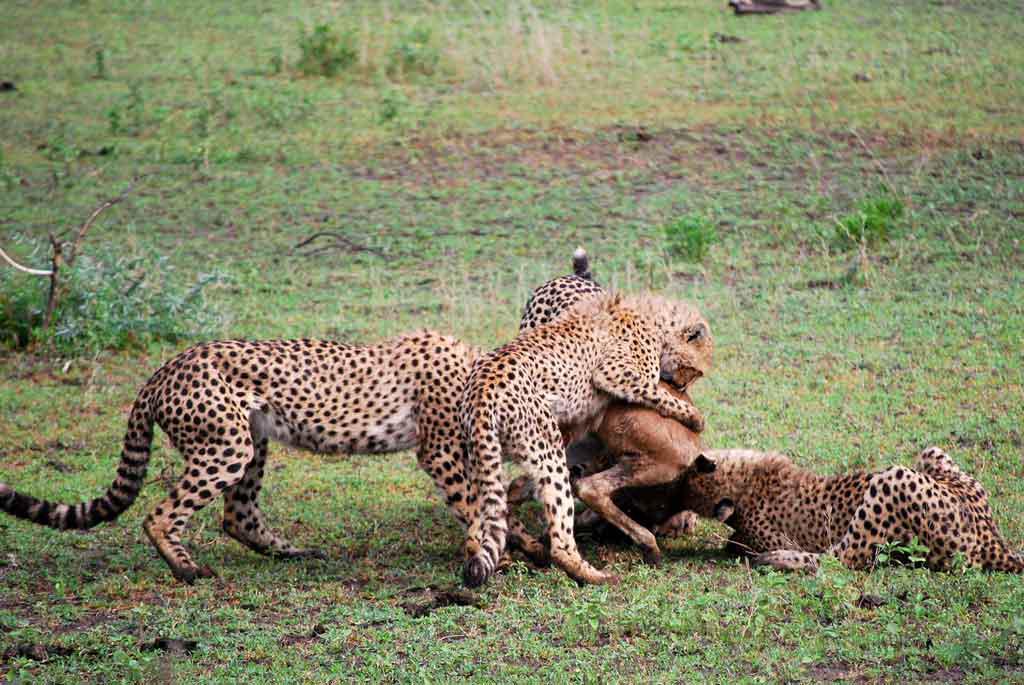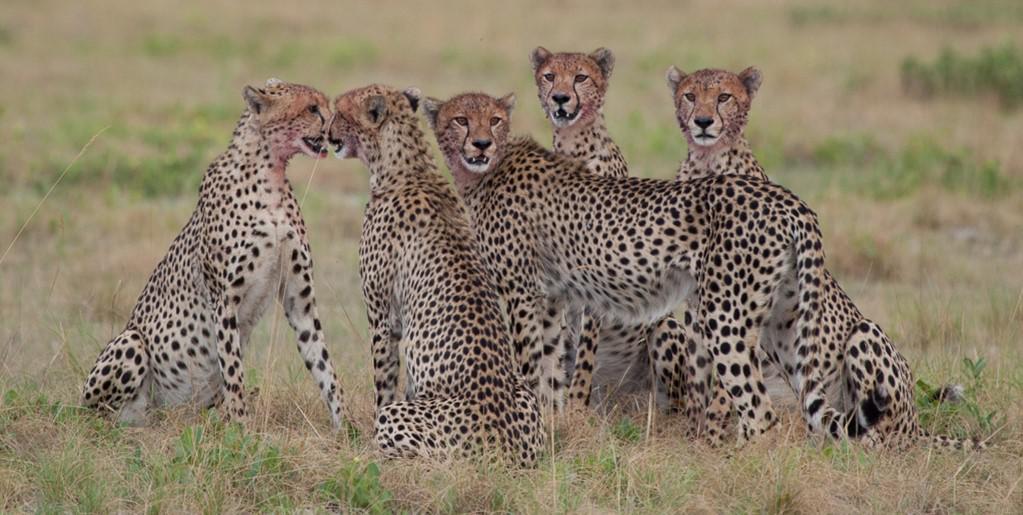The first image is the image on the left, the second image is the image on the right. Examine the images to the left and right. Is the description "There are at least four leopards." accurate? Answer yes or no. Yes. The first image is the image on the left, the second image is the image on the right. Considering the images on both sides, is "Each image contains a single cheetah, with one image showing a rightward facing cheetah, and the other showing a forward-looking cheetah." valid? Answer yes or no. No. 